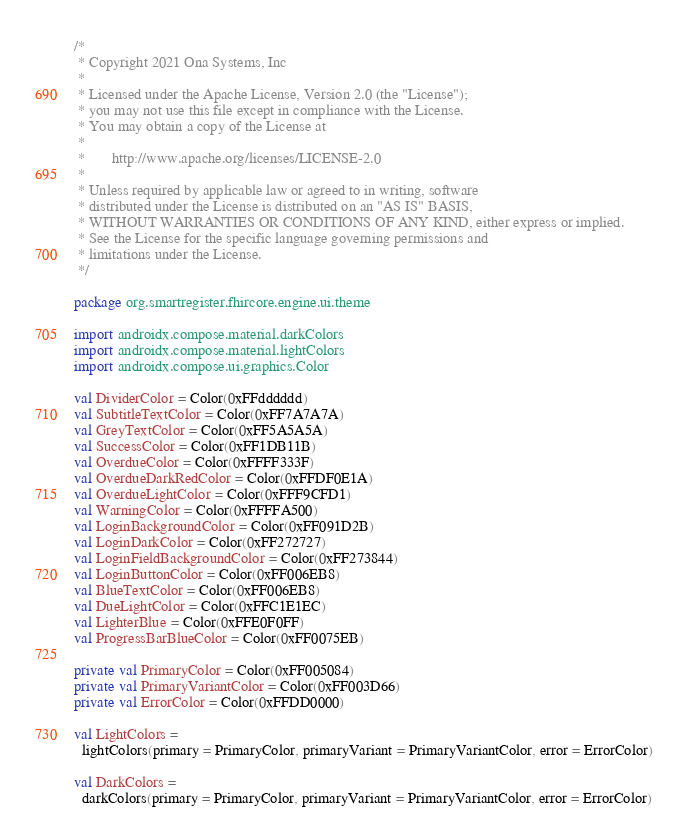Convert code to text. <code><loc_0><loc_0><loc_500><loc_500><_Kotlin_>/*
 * Copyright 2021 Ona Systems, Inc
 *
 * Licensed under the Apache License, Version 2.0 (the "License");
 * you may not use this file except in compliance with the License.
 * You may obtain a copy of the License at
 *
 *       http://www.apache.org/licenses/LICENSE-2.0
 *
 * Unless required by applicable law or agreed to in writing, software
 * distributed under the License is distributed on an "AS IS" BASIS,
 * WITHOUT WARRANTIES OR CONDITIONS OF ANY KIND, either express or implied.
 * See the License for the specific language governing permissions and
 * limitations under the License.
 */

package org.smartregister.fhircore.engine.ui.theme

import androidx.compose.material.darkColors
import androidx.compose.material.lightColors
import androidx.compose.ui.graphics.Color

val DividerColor = Color(0xFFdddddd)
val SubtitleTextColor = Color(0xFF7A7A7A)
val GreyTextColor = Color(0xFF5A5A5A)
val SuccessColor = Color(0xFF1DB11B)
val OverdueColor = Color(0xFFFF333F)
val OverdueDarkRedColor = Color(0xFFDF0E1A)
val OverdueLightColor = Color(0xFFF9CFD1)
val WarningColor = Color(0xFFFFA500)
val LoginBackgroundColor = Color(0xFF091D2B)
val LoginDarkColor = Color(0xFF272727)
val LoginFieldBackgroundColor = Color(0xFF273844)
val LoginButtonColor = Color(0xFF006EB8)
val BlueTextColor = Color(0xFF006EB8)
val DueLightColor = Color(0xFFC1E1EC)
val LighterBlue = Color(0xFFE0F0FF)
val ProgressBarBlueColor = Color(0xFF0075EB)

private val PrimaryColor = Color(0xFF005084)
private val PrimaryVariantColor = Color(0xFF003D66)
private val ErrorColor = Color(0xFFDD0000)

val LightColors =
  lightColors(primary = PrimaryColor, primaryVariant = PrimaryVariantColor, error = ErrorColor)

val DarkColors =
  darkColors(primary = PrimaryColor, primaryVariant = PrimaryVariantColor, error = ErrorColor)
</code> 